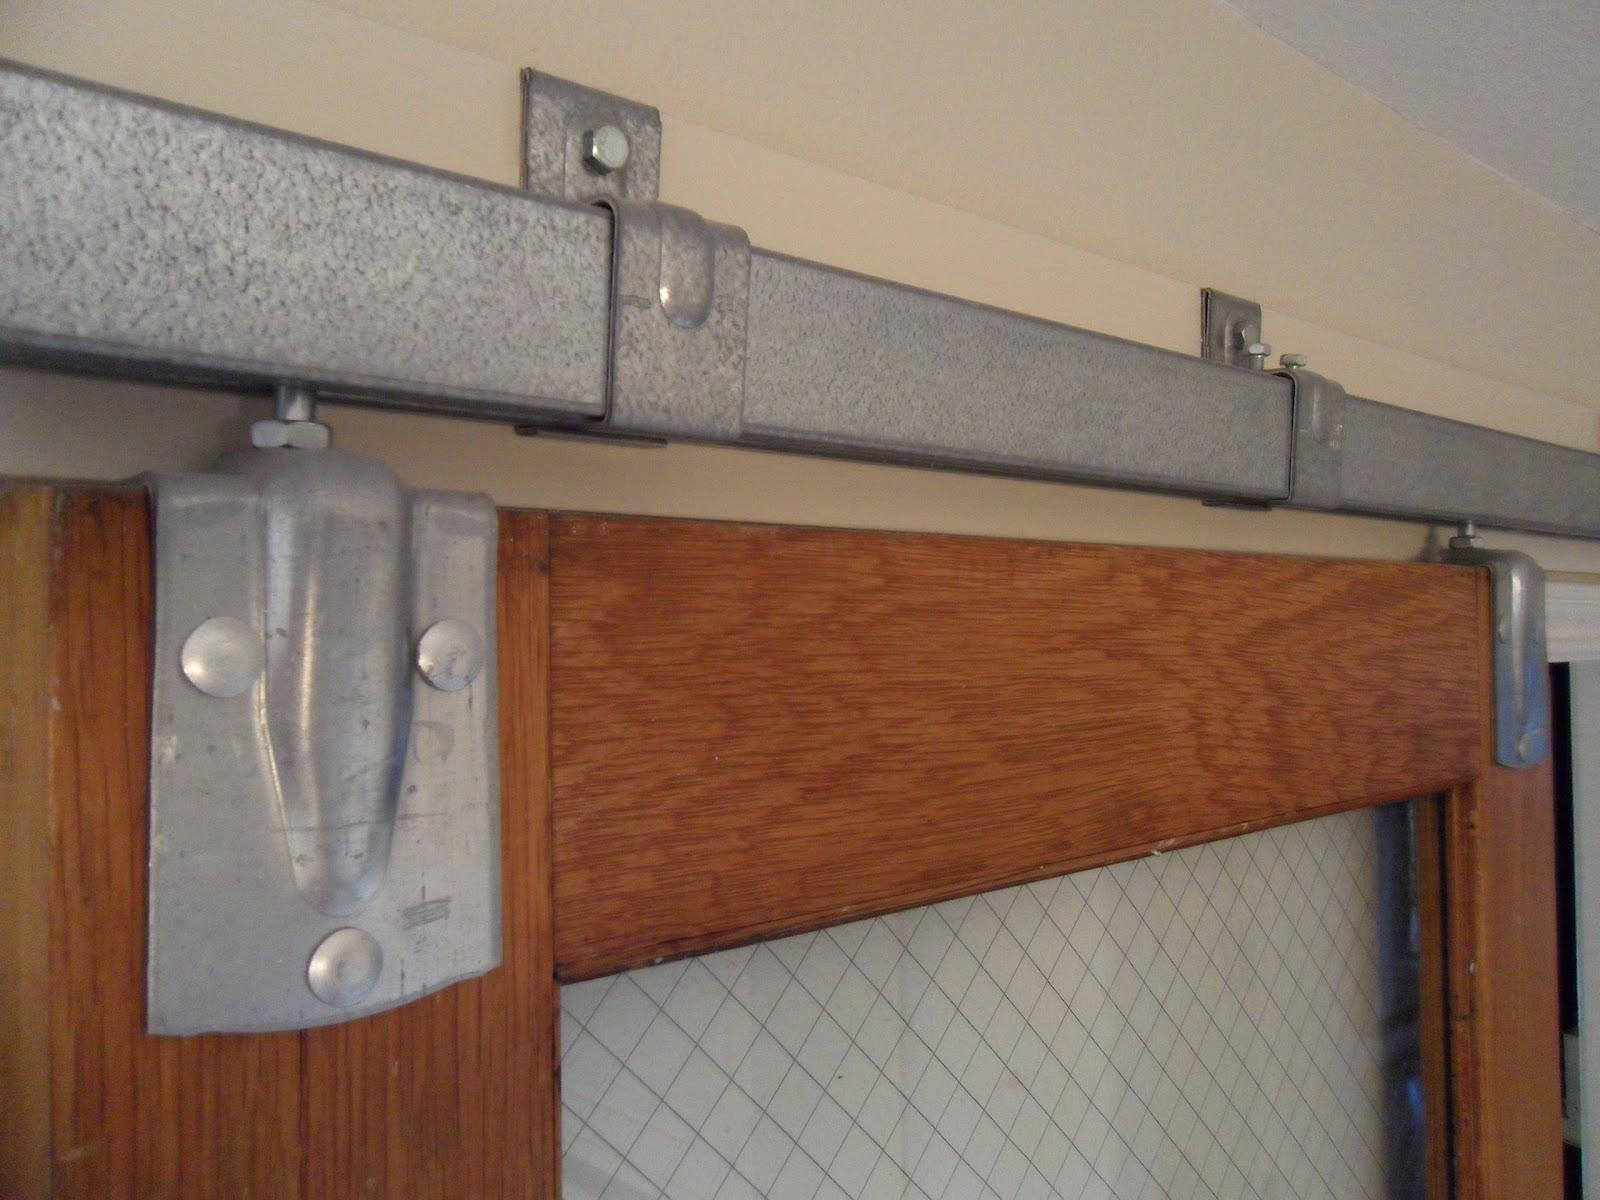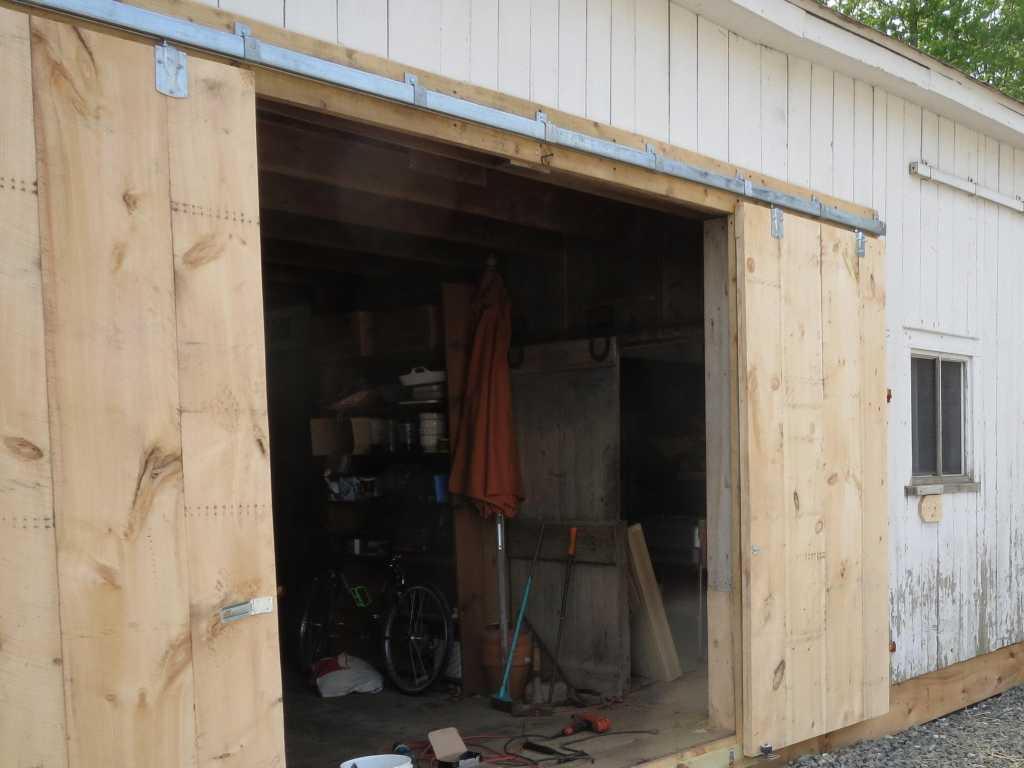The first image is the image on the left, the second image is the image on the right. For the images shown, is this caption "In one of the images the doors are open." true? Answer yes or no. Yes. 